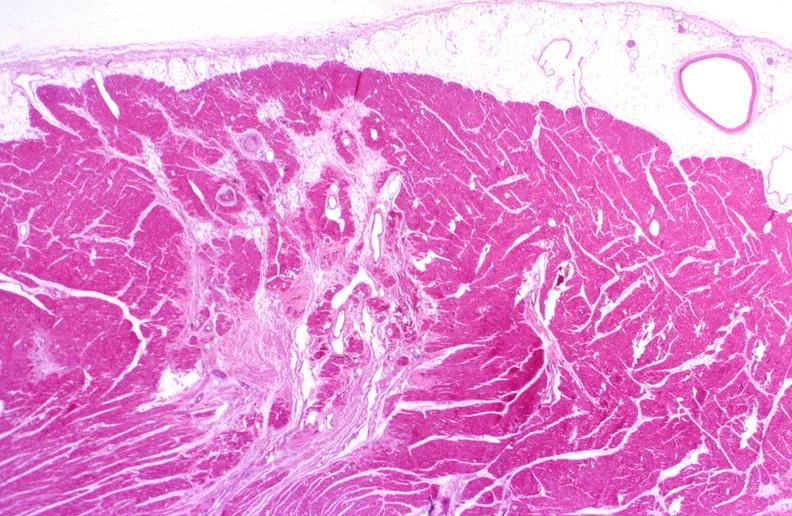does this image show heart, polyarteritis nodosa?
Answer the question using a single word or phrase. Yes 